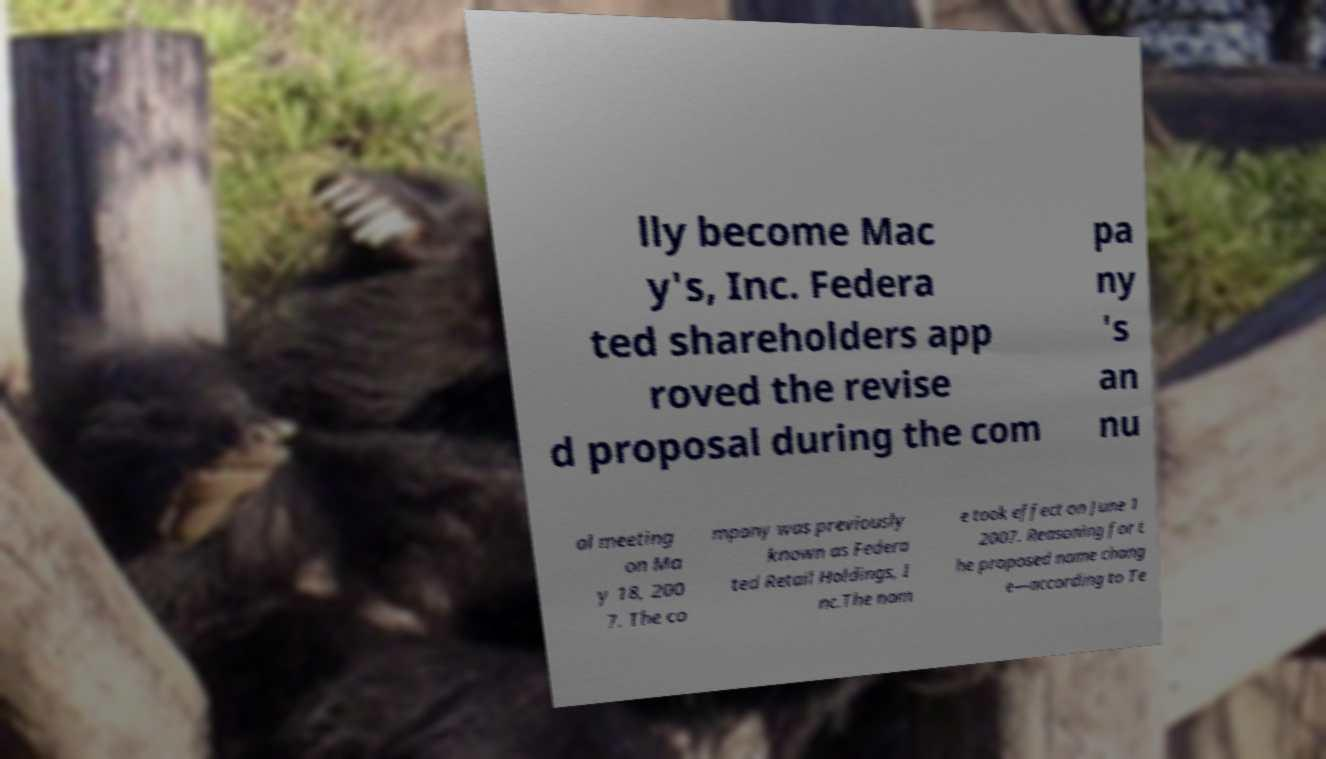Please identify and transcribe the text found in this image. lly become Mac y's, Inc. Federa ted shareholders app roved the revise d proposal during the com pa ny 's an nu al meeting on Ma y 18, 200 7. The co mpany was previously known as Federa ted Retail Holdings, I nc.The nam e took effect on June 1 2007. Reasoning for t he proposed name chang e—according to Te 